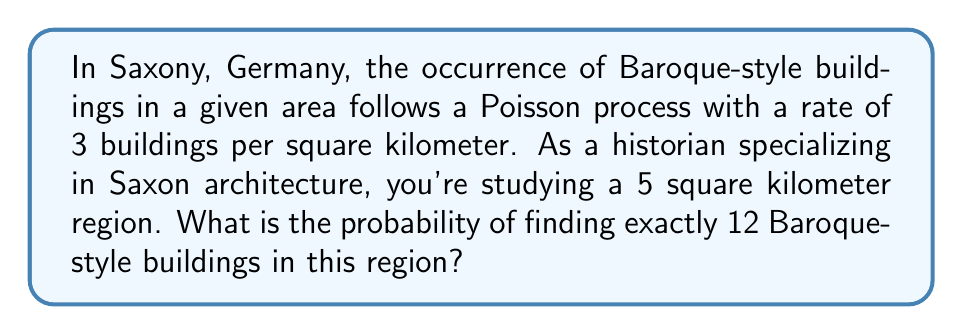What is the answer to this math problem? To solve this problem, we'll use the Poisson distribution formula. The Poisson distribution is given by:

$$P(X = k) = \frac{e^{-\lambda} \lambda^k}{k!}$$

Where:
$\lambda$ = average rate of occurrence
$k$ = number of occurrences we're interested in
$e$ = Euler's number (approximately 2.71828)

Step 1: Determine $\lambda$ for the given region
The rate is 3 buildings per square kilometer, and we're looking at a 5 square kilometer region.
$\lambda = 3 \times 5 = 15$

Step 2: Set up the Poisson formula with our values
$k = 12$ (we want exactly 12 buildings)
$\lambda = 15$

$$P(X = 12) = \frac{e^{-15} 15^{12}}{12!}$$

Step 3: Calculate the result
Using a calculator or computer:

$$P(X = 12) = \frac{e^{-15} 15^{12}}{12!} \approx 0.0705$$

Step 4: Interpret the result
The probability of finding exactly 12 Baroque-style buildings in the 5 square kilometer region is approximately 0.0705 or 7.05%.
Answer: 0.0705 (or 7.05%) 